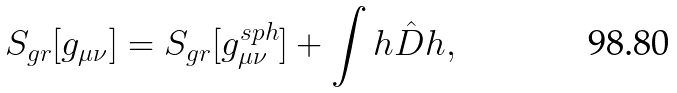<formula> <loc_0><loc_0><loc_500><loc_500>S _ { g r } [ g _ { \mu \nu } ] = S _ { g r } [ g _ { \mu \nu } ^ { s p h } ] + \int h \hat { D } h ,</formula> 